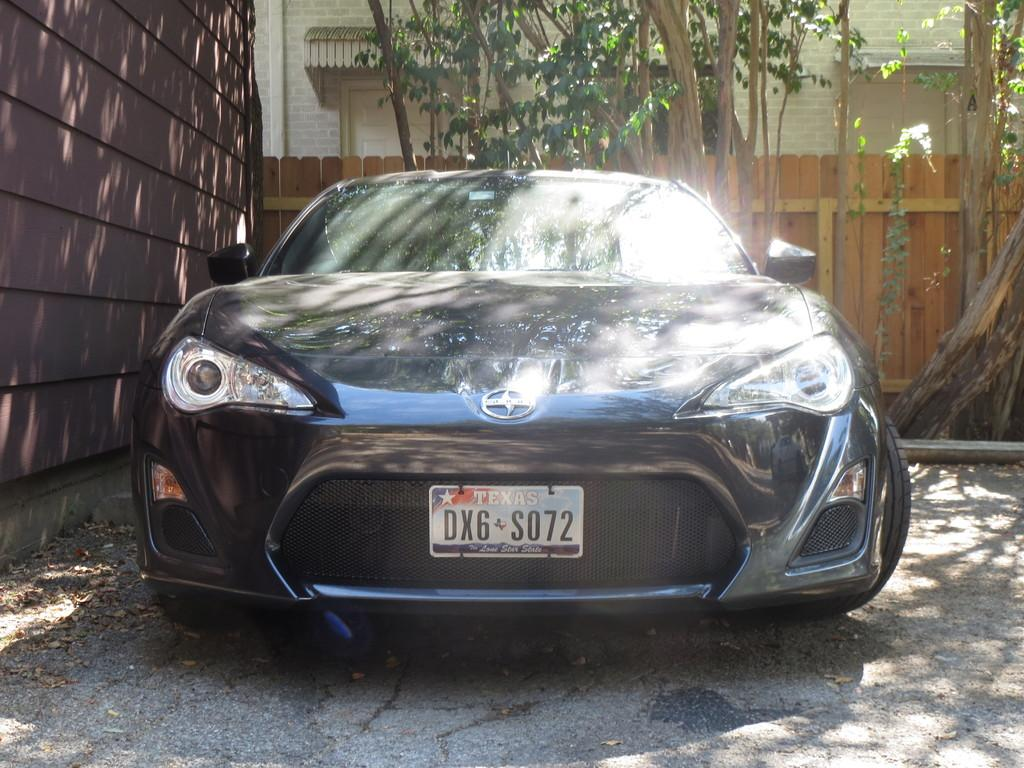What is the main subject of the image? There is a car in the image. What can be seen on the left side of the image? There is a wall on the left side of the image. What type of natural elements are visible in the image? There are visible at the back side of the image? Where is the scarecrow located in the image? There is no scarecrow present in the image. What type of brake is used in the car in the image? The image does not provide information about the type of brake used in the car. 